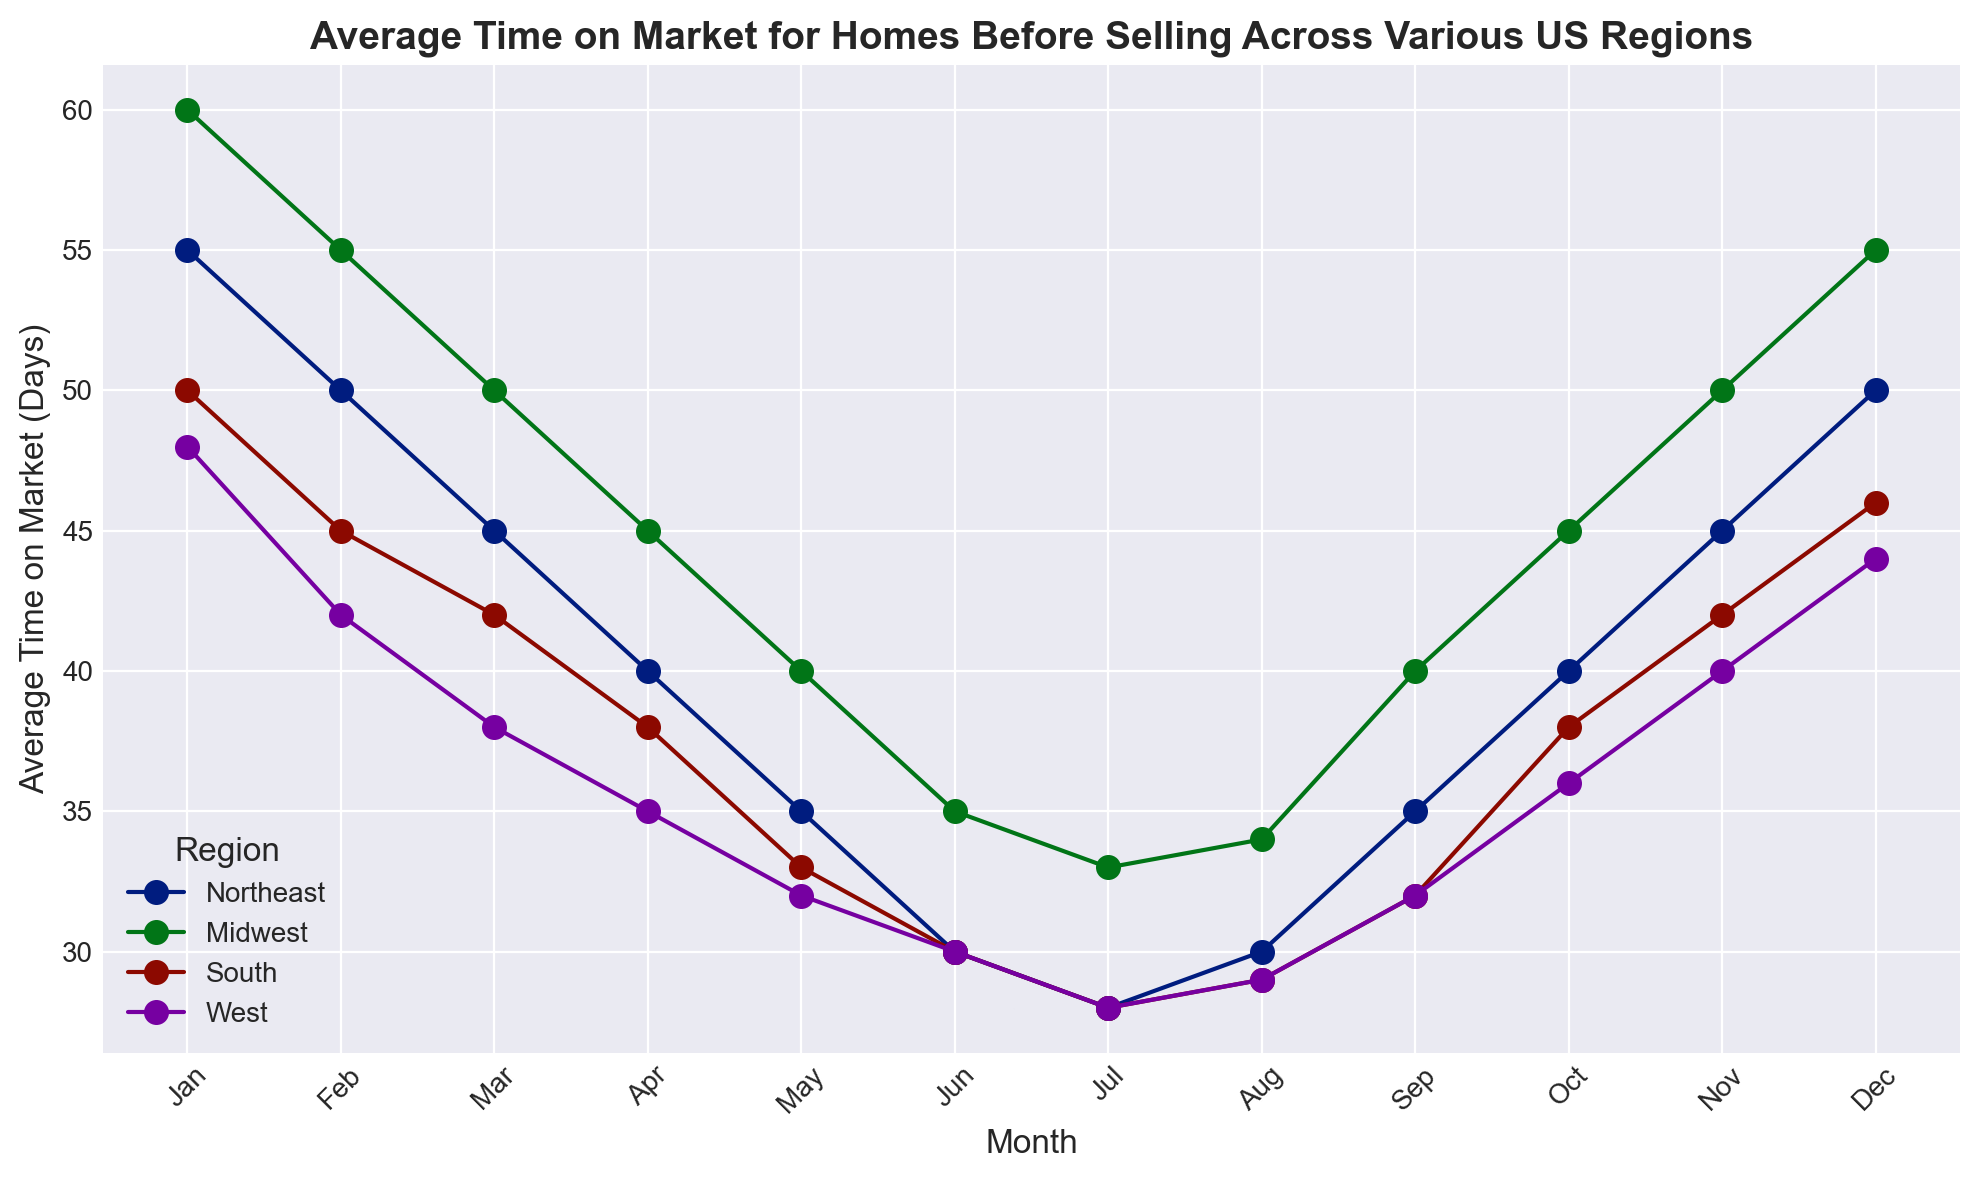What month has the shortest average time on market for homes in the Midwest region? The plot shows that the Midwest region has the shortest average time on market in July, with homes staying on the market for 33 days.
Answer: July Which region experiences the largest range in average time on market throughout the year? By comparing the highest and lowest average times on market for each region from the plot, we see that the Midwest region varies between 60 days in January and 33 days in July, resulting in a range of 27 days, which is larger than the other regions.
Answer: Midwest Which month has the longest average time on market for homes in the South region? Observing the lines for the South region, we see that January has the longest average time on market, which is 50 days.
Answer: January How does the average time on market in the Northeast compare between May and September? For the Northeast region, according to the plot, the average time on market is 35 days in both May and September, indicating no difference.
Answer: Equal What trend is noticeable in the West region from January to July? The plotted line for the West region indicates a downward trend in the average time on market, starting at 48 days in January and declining to 28 days in July.
Answer: Downward trend How does the average time on market in July compare between the Northeast and South regions? By comparing the lines for July, the Northeast region has an average time on market of 28 days, while the South region has an average of 28 days as well, indicating they are the same.
Answer: Equal Calculate the average of the average time on market across all regions for June. The average time on market in June is: (30 days for Northeast + 35 days for Midwest + 30 days for South + 30 days for West) / 4 = 31.25 days.
Answer: 31.25 days Which region has the most consistent average time on market throughout the year (smallest variation)? Assessing the plot, the West region shows the smallest variation, with a high of 48 days in January and a low of 28 days in July, indicating a range of 20 days.
Answer: West In which region does the average time on market increase the most from August to October? The largest increase in average time on market is observed in the West region, where the time increases from 29 days in August to 36 days in October, an increase of 7 days.
Answer: West 